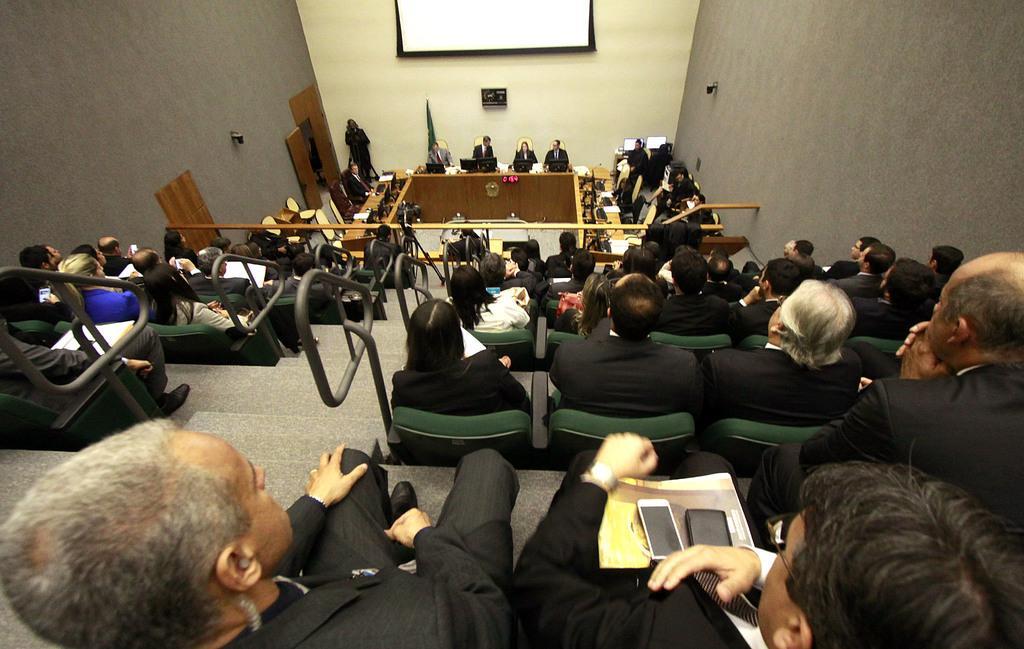Please provide a concise description of this image. This image is clicked inside the hall where we can see that there are few officers sitting in the middle. At the top there is screen. At the bottom there are so many people sitting in the chairs. There is wall on either side of the image. At the bottom there are computers on the table. At the bottom there is a person sitting in the chair by holding the book. On the book there are two mobile phones. 